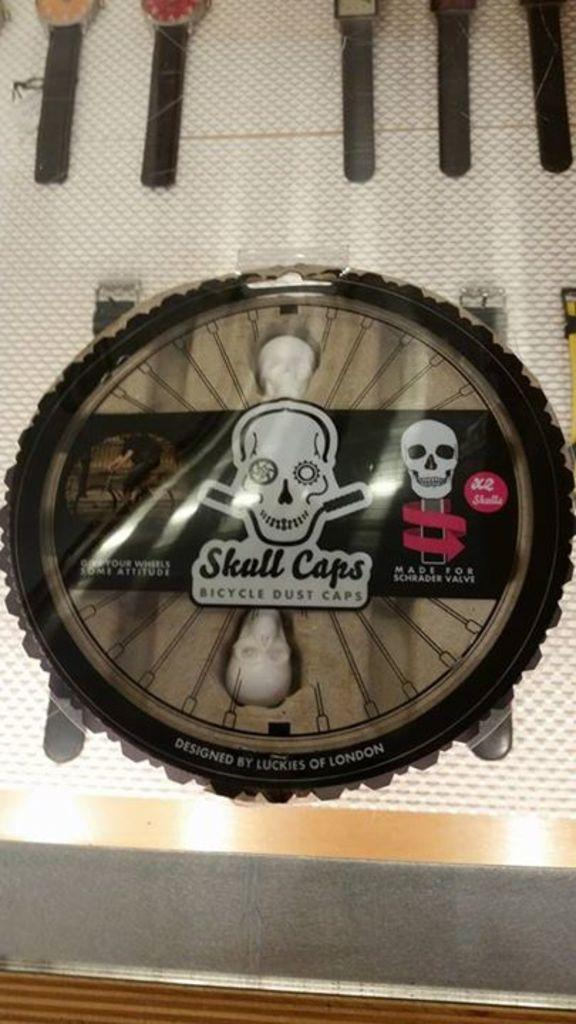What is the main feature of the picture? There is a logo in the picture. What can be seen within the logo? The logo contains skeleton images. Is there any text associated with the logo? Yes, there is text associated with the logo. What can be seen in the background of the picture? In the background, there are wrist watches. What is the color of the surface on which the wrist watches are placed? The wrist watches are placed on a white surface. What song is being played in the background of the image? There is no mention of any song being played in the image. The image primarily features a logo with skeleton images and text, along with wrist watches in the background. --- Facts: 1. There is a person holding a camera in the image. 2. The person is wearing a hat. 3. The person is standing near a tree. 4. The tree has green leaves. 5. The sky is visible in the image. Absurd Topics: bicycle, ocean, birdhouse Conversation: What is the person in the image doing? The person in the image is holding a camera. Can you describe the person's attire? The person is wearing a hat. Where is the person standing in the image? The person is standing near a tree. What is the condition of the tree's leaves? The tree has green leaves. What can be seen in the background of the image? The sky is visible in the image. Reasoning: Let's think step by step in order to produce the conversation. We start by identifying the main subject of the image, which is the person holding a camera. Then, we describe the person's attire, mentioning the presence of a hat. Next, we acknowledge the person's location in the image, noting that they are standing near a tree. After that, we describe the condition of the tree's leaves, mentioning that they are green. Finally, we describe the background of the image, noting that the sky is visible. Absurd Question/Answer: Where is the birdhouse located in the image? There is no birdhouse present in the image. The image primarily features a person holding a camera, wearing a hat, standing near a tree with green leaves, and the sky visible in the background. 